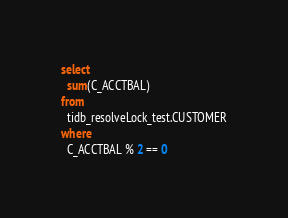<code> <loc_0><loc_0><loc_500><loc_500><_SQL_>select
  sum(C_ACCTBAL)
from
  tidb_resolveLock_test.CUSTOMER
where
  C_ACCTBAL % 2 == 0</code> 